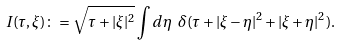Convert formula to latex. <formula><loc_0><loc_0><loc_500><loc_500>I ( \tau , \xi ) \colon = \sqrt { \tau + | \xi | ^ { 2 } } \int d \eta \ \delta ( \tau + | \xi - \eta | ^ { 2 } + | \xi + \eta | ^ { 2 } ) .</formula> 